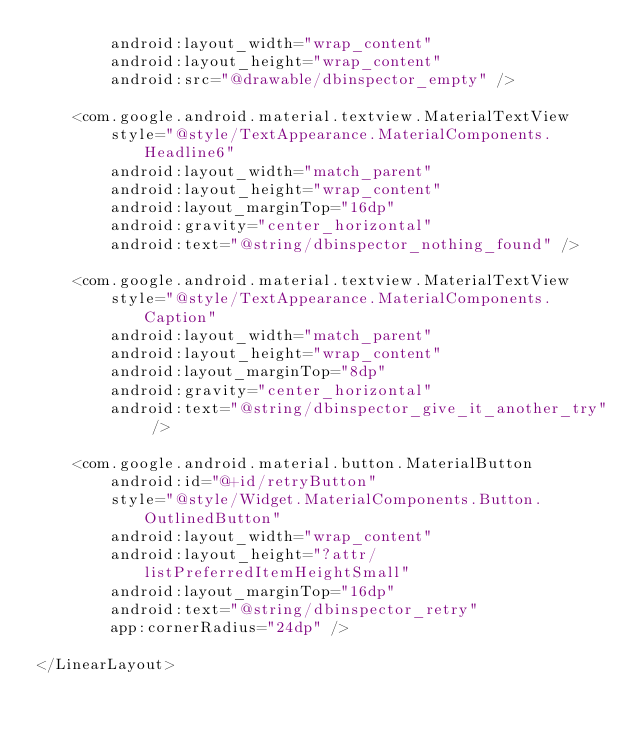Convert code to text. <code><loc_0><loc_0><loc_500><loc_500><_XML_>        android:layout_width="wrap_content"
        android:layout_height="wrap_content"
        android:src="@drawable/dbinspector_empty" />

    <com.google.android.material.textview.MaterialTextView
        style="@style/TextAppearance.MaterialComponents.Headline6"
        android:layout_width="match_parent"
        android:layout_height="wrap_content"
        android:layout_marginTop="16dp"
        android:gravity="center_horizontal"
        android:text="@string/dbinspector_nothing_found" />

    <com.google.android.material.textview.MaterialTextView
        style="@style/TextAppearance.MaterialComponents.Caption"
        android:layout_width="match_parent"
        android:layout_height="wrap_content"
        android:layout_marginTop="8dp"
        android:gravity="center_horizontal"
        android:text="@string/dbinspector_give_it_another_try" />

    <com.google.android.material.button.MaterialButton
        android:id="@+id/retryButton"
        style="@style/Widget.MaterialComponents.Button.OutlinedButton"
        android:layout_width="wrap_content"
        android:layout_height="?attr/listPreferredItemHeightSmall"
        android:layout_marginTop="16dp"
        android:text="@string/dbinspector_retry"
        app:cornerRadius="24dp" />

</LinearLayout></code> 